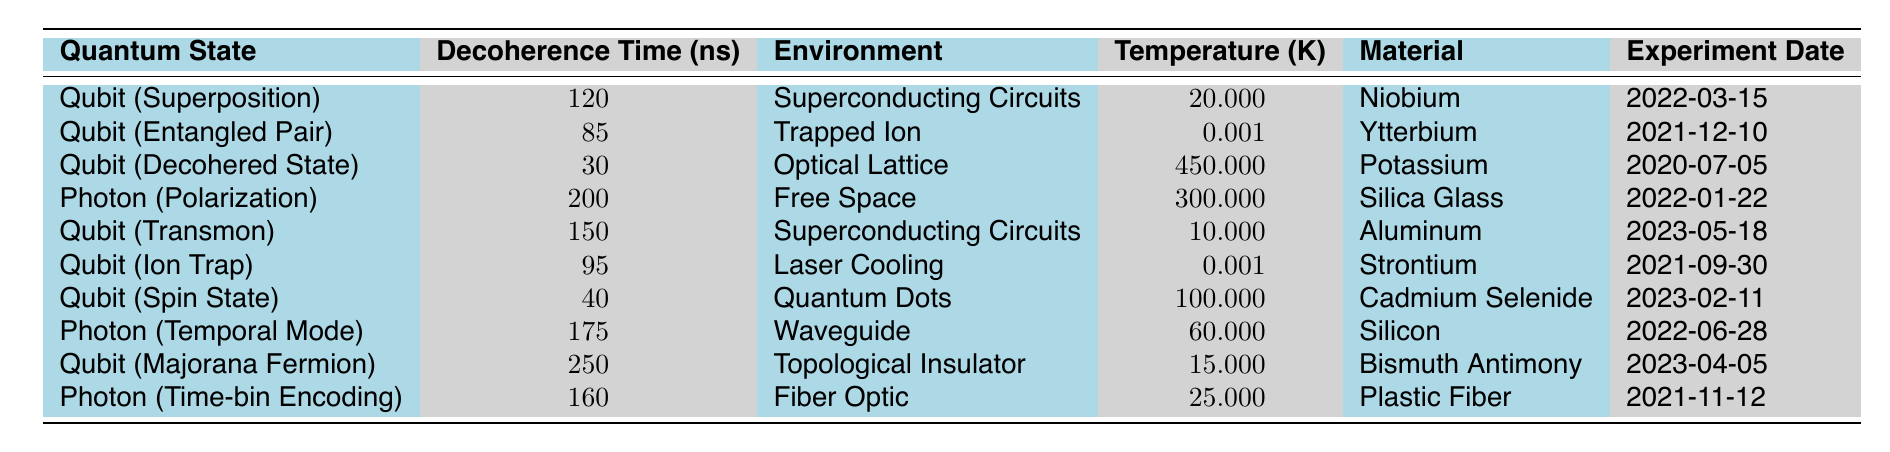What is the decoherence time for the Qubit (Superposition)? The decoherence time for the Qubit (Superposition) can be found directly in the table. It shows 120 nanoseconds for this quantum state.
Answer: 120 ns Which quantum state has the highest decoherence time? By looking at the decoherence times in the table, the highest value is 250 ns, which corresponds to the Qubit (Majorana Fermion).
Answer: Qubit (Majorana Fermion) What material is used for the Photon (Polarization) quantum state? The material associated with the Photon (Polarization) is listed as Silica Glass in the table.
Answer: Silica Glass Is the decoherence time of the Qubit (Decohered State) greater than that of the Qubit (Entangled Pair)? The decoherence time for the Qubit (Decohered State) is 30 ns, while for the Qubit (Entangled Pair) it is 85 ns. Since 30 ns is less than 85 ns, the statement is false.
Answer: No What is the average decoherence time of Qubits in this table? The decoherence times for the Qubits are 120, 85, 30, 150, 95, 40, and 250. Adding these gives 120 + 85 + 30 + 150 + 95 + 40 + 250 = 770 ns. There are 7 Qubits, so the average is 770/7 = approximately 110 ns.
Answer: ~110 ns Which quantum states are part of Superconducting Circuits? From the table, there are two quantum states in Superconducting Circuits: Qubit (Superposition) with 120 ns and Qubit (Transmon) with 150 ns.
Answer: Qubit (Superposition) and Qubit (Transmon) What is the temperature for the Qubit (Ion Trap) experiment? The temperature for the Qubit (Ion Trap) is recorded in the table as 0.0005 K.
Answer: 0.0005 K Which quantum state has a longer decoherence time: Photon (Temporal Mode) or Qubit (Spin State)? The decoherence time for Photon (Temporal Mode) is 175 ns compared to 40 ns for Qubit (Spin State). Since 175 ns is greater than 40 ns, Photon (Temporal Mode) has a longer decoherence time.
Answer: Photon (Temporal Mode) What is the difference in decoherence time between Qubit (Majorana Fermion) and Qubit (Decohered State)? The decoherence time for Qubit (Majorana Fermion) is 250 ns and for Qubit (Decohered State) is 30 ns. The difference is 250 - 30 = 220 ns.
Answer: 220 ns List all quantum states that operate at temperatures below 50 K. The table shows Qubit (Entangled Pair) at 0.001 K, Qubit (Ion Trap) at 0.001 K, Qubit (Spin State) at 100 K (not included), and Qubit (Majorana Fermion) at 15 K. Thus, the states with temperatures below 50 K are Qubit (Entangled Pair), Qubit (Ion Trap), and Qubit (Majorana Fermion).
Answer: Qubit (Entangled Pair), Qubit (Ion Trap), Qubit (Majorana Fermion) Is there any photon state with a decoherence time greater than 160 ns? The table shows Photon (Temporal Mode) with 175 ns and Photon (Time-bin Encoding) with 160 ns. Since 175 ns is greater than 160 ns, the answer is yes.
Answer: Yes 